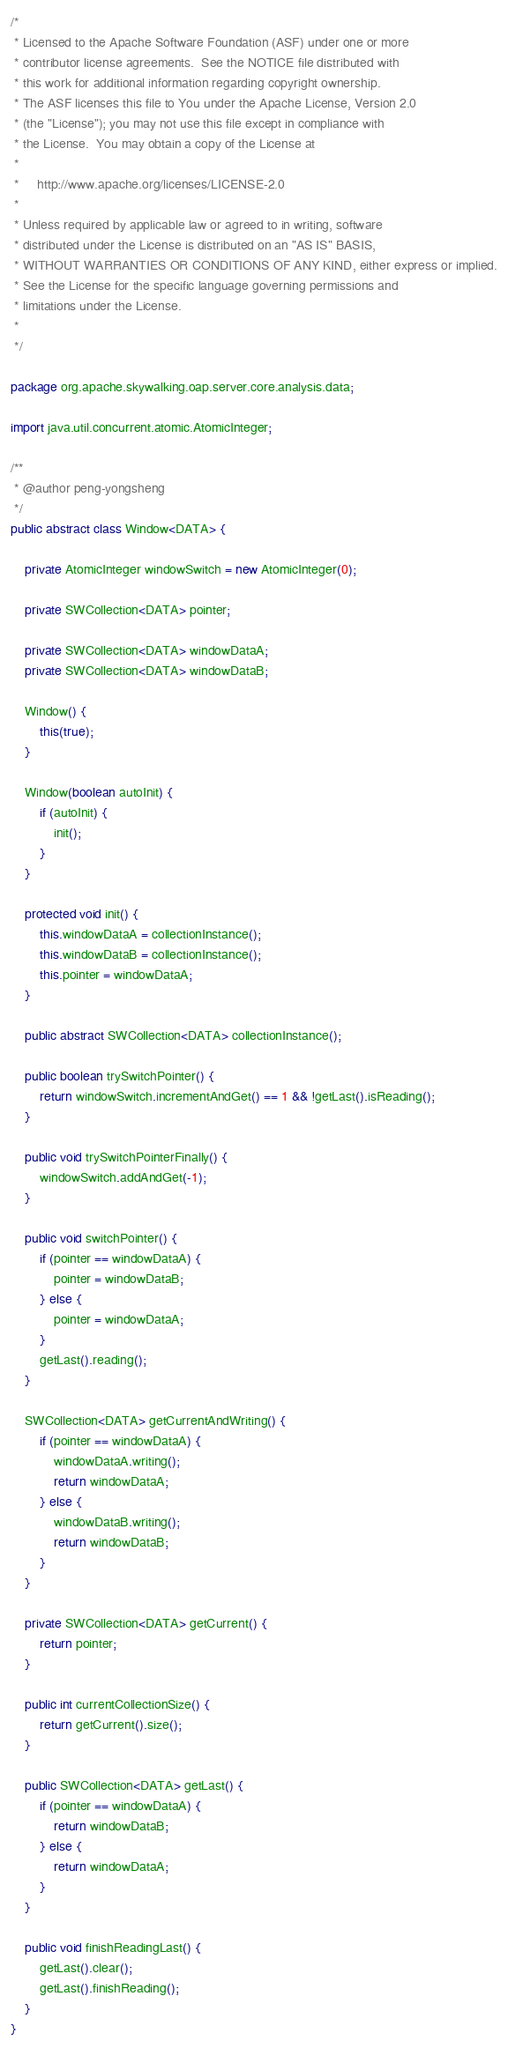<code> <loc_0><loc_0><loc_500><loc_500><_Java_>/*
 * Licensed to the Apache Software Foundation (ASF) under one or more
 * contributor license agreements.  See the NOTICE file distributed with
 * this work for additional information regarding copyright ownership.
 * The ASF licenses this file to You under the Apache License, Version 2.0
 * (the "License"); you may not use this file except in compliance with
 * the License.  You may obtain a copy of the License at
 *
 *     http://www.apache.org/licenses/LICENSE-2.0
 *
 * Unless required by applicable law or agreed to in writing, software
 * distributed under the License is distributed on an "AS IS" BASIS,
 * WITHOUT WARRANTIES OR CONDITIONS OF ANY KIND, either express or implied.
 * See the License for the specific language governing permissions and
 * limitations under the License.
 *
 */

package org.apache.skywalking.oap.server.core.analysis.data;

import java.util.concurrent.atomic.AtomicInteger;

/**
 * @author peng-yongsheng
 */
public abstract class Window<DATA> {

    private AtomicInteger windowSwitch = new AtomicInteger(0);

    private SWCollection<DATA> pointer;

    private SWCollection<DATA> windowDataA;
    private SWCollection<DATA> windowDataB;

    Window() {
        this(true);
    }

    Window(boolean autoInit) {
        if (autoInit) {
            init();
        }
    }

    protected void init() {
        this.windowDataA = collectionInstance();
        this.windowDataB = collectionInstance();
        this.pointer = windowDataA;
    }

    public abstract SWCollection<DATA> collectionInstance();

    public boolean trySwitchPointer() {
        return windowSwitch.incrementAndGet() == 1 && !getLast().isReading();
    }

    public void trySwitchPointerFinally() {
        windowSwitch.addAndGet(-1);
    }

    public void switchPointer() {
        if (pointer == windowDataA) {
            pointer = windowDataB;
        } else {
            pointer = windowDataA;
        }
        getLast().reading();
    }

    SWCollection<DATA> getCurrentAndWriting() {
        if (pointer == windowDataA) {
            windowDataA.writing();
            return windowDataA;
        } else {
            windowDataB.writing();
            return windowDataB;
        }
    }

    private SWCollection<DATA> getCurrent() {
        return pointer;
    }

    public int currentCollectionSize() {
        return getCurrent().size();
    }

    public SWCollection<DATA> getLast() {
        if (pointer == windowDataA) {
            return windowDataB;
        } else {
            return windowDataA;
        }
    }

    public void finishReadingLast() {
        getLast().clear();
        getLast().finishReading();
    }
}
</code> 